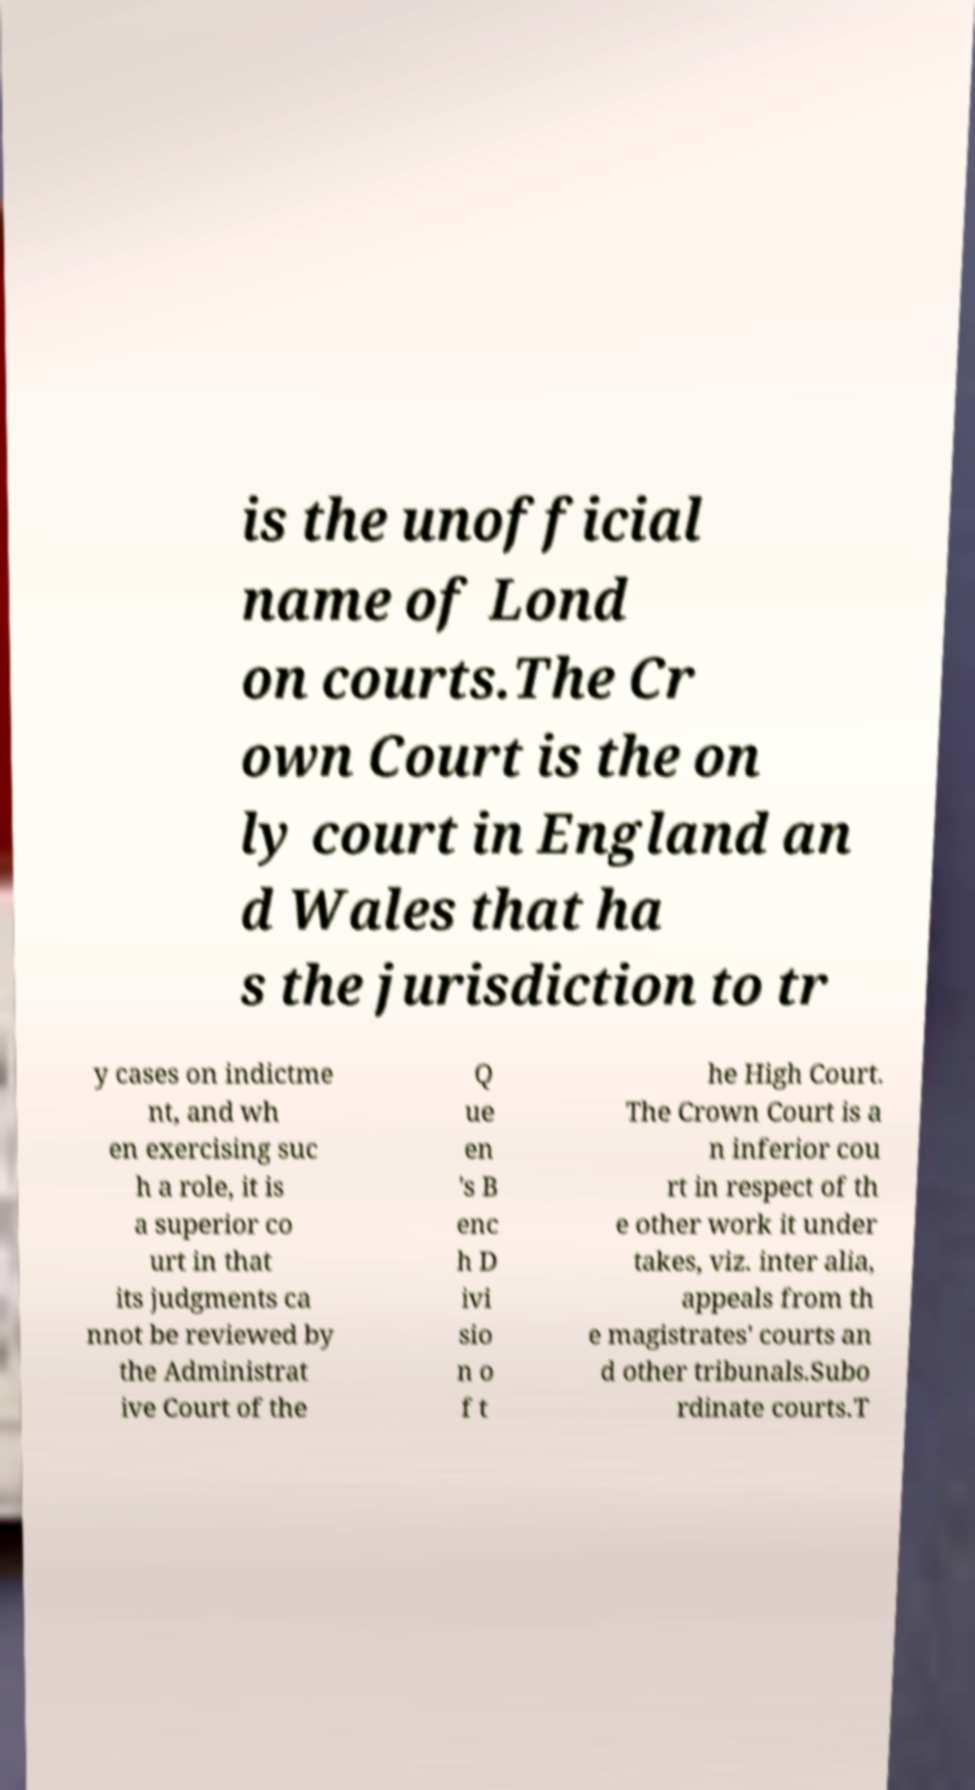Could you assist in decoding the text presented in this image and type it out clearly? is the unofficial name of Lond on courts.The Cr own Court is the on ly court in England an d Wales that ha s the jurisdiction to tr y cases on indictme nt, and wh en exercising suc h a role, it is a superior co urt in that its judgments ca nnot be reviewed by the Administrat ive Court of the Q ue en 's B enc h D ivi sio n o f t he High Court. The Crown Court is a n inferior cou rt in respect of th e other work it under takes, viz. inter alia, appeals from th e magistrates' courts an d other tribunals.Subo rdinate courts.T 